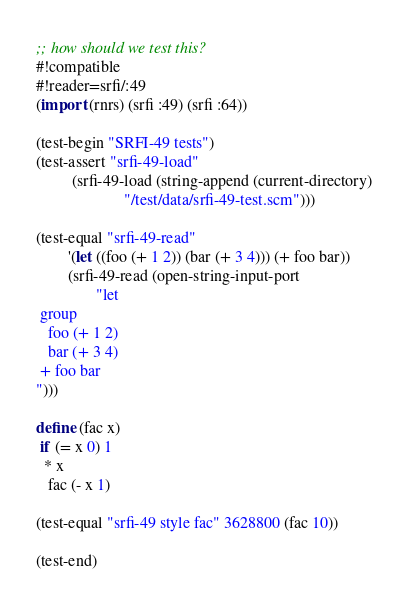Convert code to text. <code><loc_0><loc_0><loc_500><loc_500><_Scheme_>;; how should we test this?
#!compatible
#!reader=srfi/:49
(import (rnrs) (srfi :49) (srfi :64))

(test-begin "SRFI-49 tests")
(test-assert "srfi-49-load"
	     (srfi-49-load (string-append (current-directory)
					  "/test/data/srfi-49-test.scm")))

(test-equal "srfi-49-read"
	    '(let ((foo (+ 1 2)) (bar (+ 3 4))) (+ foo bar))
	    (srfi-49-read (open-string-input-port
			   "let
 group
   foo (+ 1 2)
   bar (+ 3 4)
 + foo bar
")))

define (fac x)
 if (= x 0) 1
  * x
   fac (- x 1)

(test-equal "srfi-49 style fac" 3628800 (fac 10))

(test-end)
</code> 